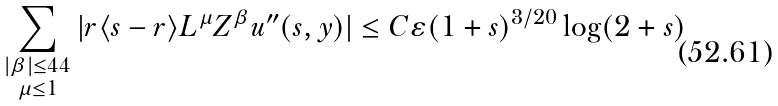<formula> <loc_0><loc_0><loc_500><loc_500>\sum _ { \substack { | \beta | \leq 4 4 \\ \mu \leq 1 } } | r \langle s - r \rangle L ^ { \mu } Z ^ { \beta } u ^ { \prime \prime } ( s , y ) | \leq C \varepsilon ( 1 + s ) ^ { 3 / 2 0 } \log ( 2 + s )</formula> 